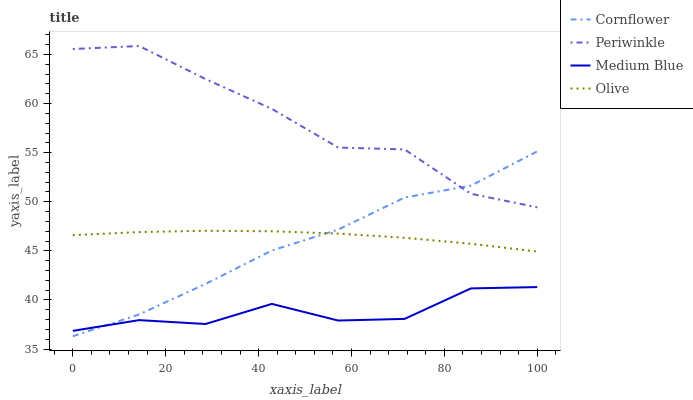Does Medium Blue have the minimum area under the curve?
Answer yes or no. Yes. Does Periwinkle have the maximum area under the curve?
Answer yes or no. Yes. Does Cornflower have the minimum area under the curve?
Answer yes or no. No. Does Cornflower have the maximum area under the curve?
Answer yes or no. No. Is Olive the smoothest?
Answer yes or no. Yes. Is Periwinkle the roughest?
Answer yes or no. Yes. Is Cornflower the smoothest?
Answer yes or no. No. Is Cornflower the roughest?
Answer yes or no. No. Does Cornflower have the lowest value?
Answer yes or no. Yes. Does Periwinkle have the lowest value?
Answer yes or no. No. Does Periwinkle have the highest value?
Answer yes or no. Yes. Does Cornflower have the highest value?
Answer yes or no. No. Is Medium Blue less than Olive?
Answer yes or no. Yes. Is Periwinkle greater than Medium Blue?
Answer yes or no. Yes. Does Olive intersect Cornflower?
Answer yes or no. Yes. Is Olive less than Cornflower?
Answer yes or no. No. Is Olive greater than Cornflower?
Answer yes or no. No. Does Medium Blue intersect Olive?
Answer yes or no. No. 